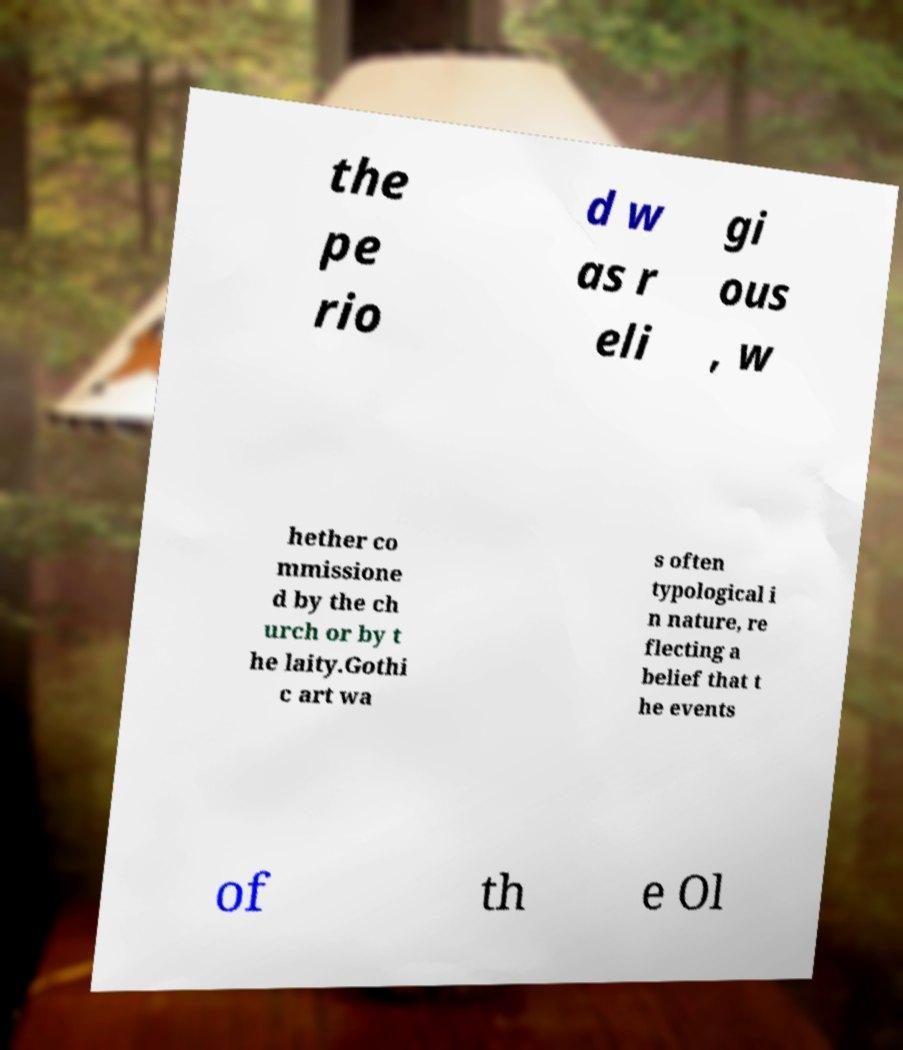Could you extract and type out the text from this image? the pe rio d w as r eli gi ous , w hether co mmissione d by the ch urch or by t he laity.Gothi c art wa s often typological i n nature, re flecting a belief that t he events of th e Ol 